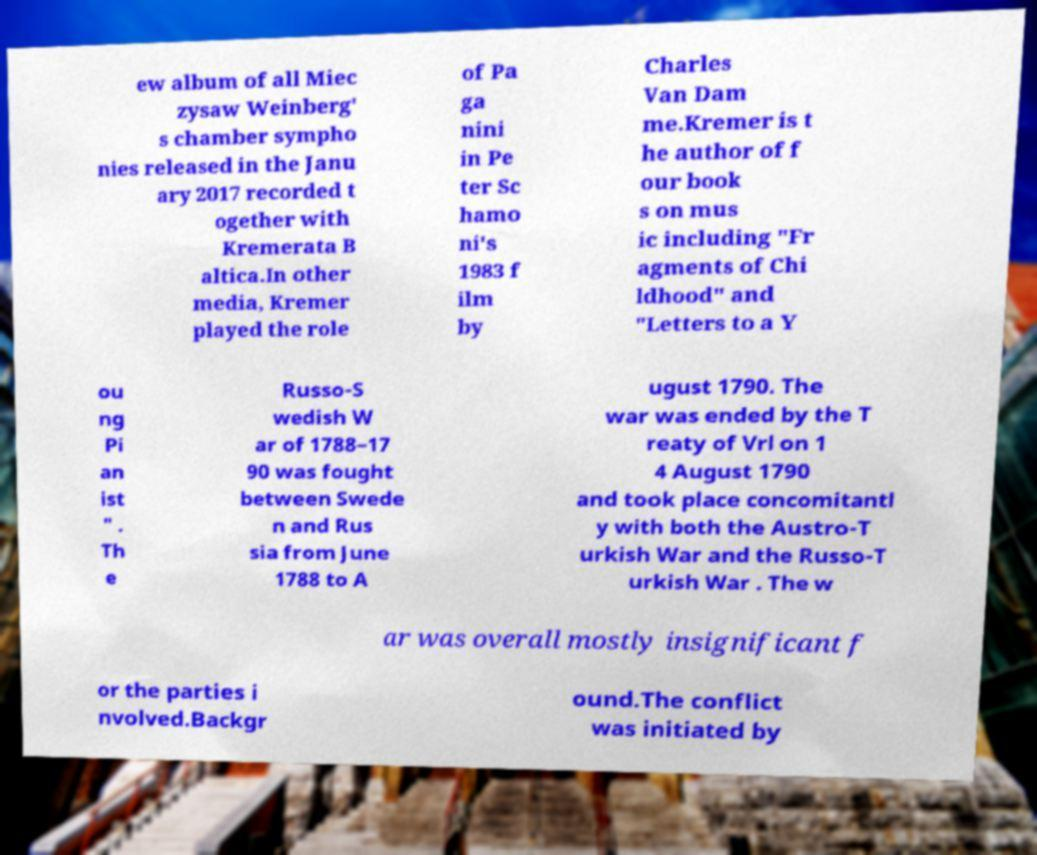Please identify and transcribe the text found in this image. ew album of all Miec zysaw Weinberg' s chamber sympho nies released in the Janu ary 2017 recorded t ogether with Kremerata B altica.In other media, Kremer played the role of Pa ga nini in Pe ter Sc hamo ni's 1983 f ilm by Charles Van Dam me.Kremer is t he author of f our book s on mus ic including "Fr agments of Chi ldhood" and "Letters to a Y ou ng Pi an ist " . Th e Russo-S wedish W ar of 1788–17 90 was fought between Swede n and Rus sia from June 1788 to A ugust 1790. The war was ended by the T reaty of Vrl on 1 4 August 1790 and took place concomitantl y with both the Austro-T urkish War and the Russo-T urkish War . The w ar was overall mostly insignificant f or the parties i nvolved.Backgr ound.The conflict was initiated by 